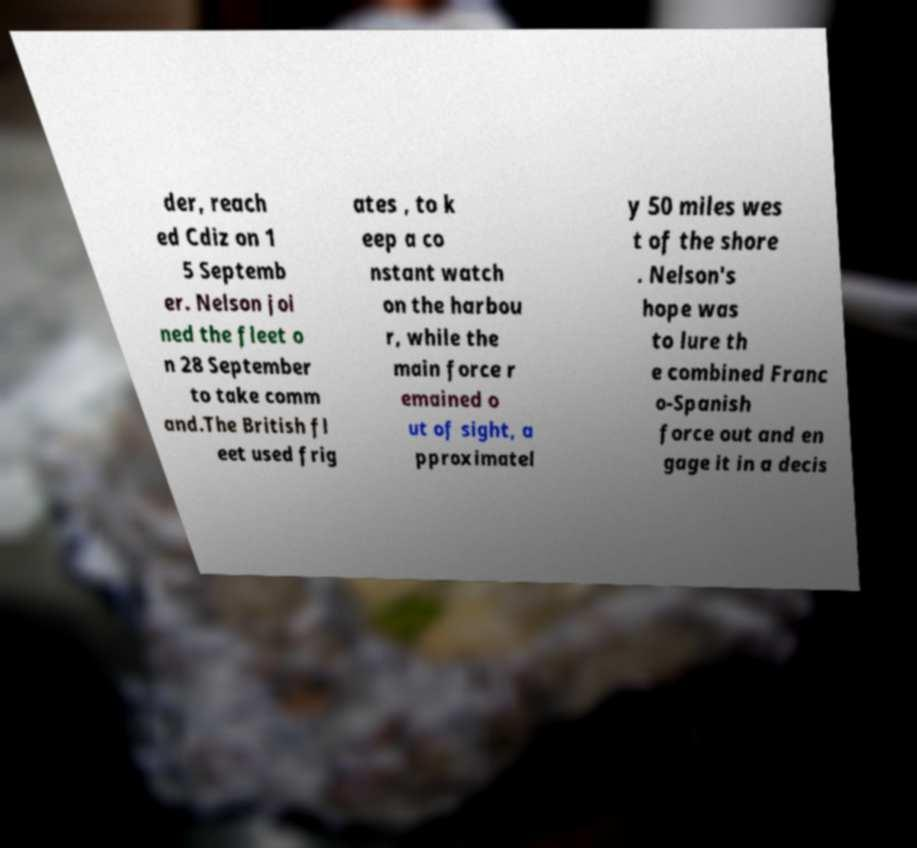I need the written content from this picture converted into text. Can you do that? der, reach ed Cdiz on 1 5 Septemb er. Nelson joi ned the fleet o n 28 September to take comm and.The British fl eet used frig ates , to k eep a co nstant watch on the harbou r, while the main force r emained o ut of sight, a pproximatel y 50 miles wes t of the shore . Nelson's hope was to lure th e combined Franc o-Spanish force out and en gage it in a decis 